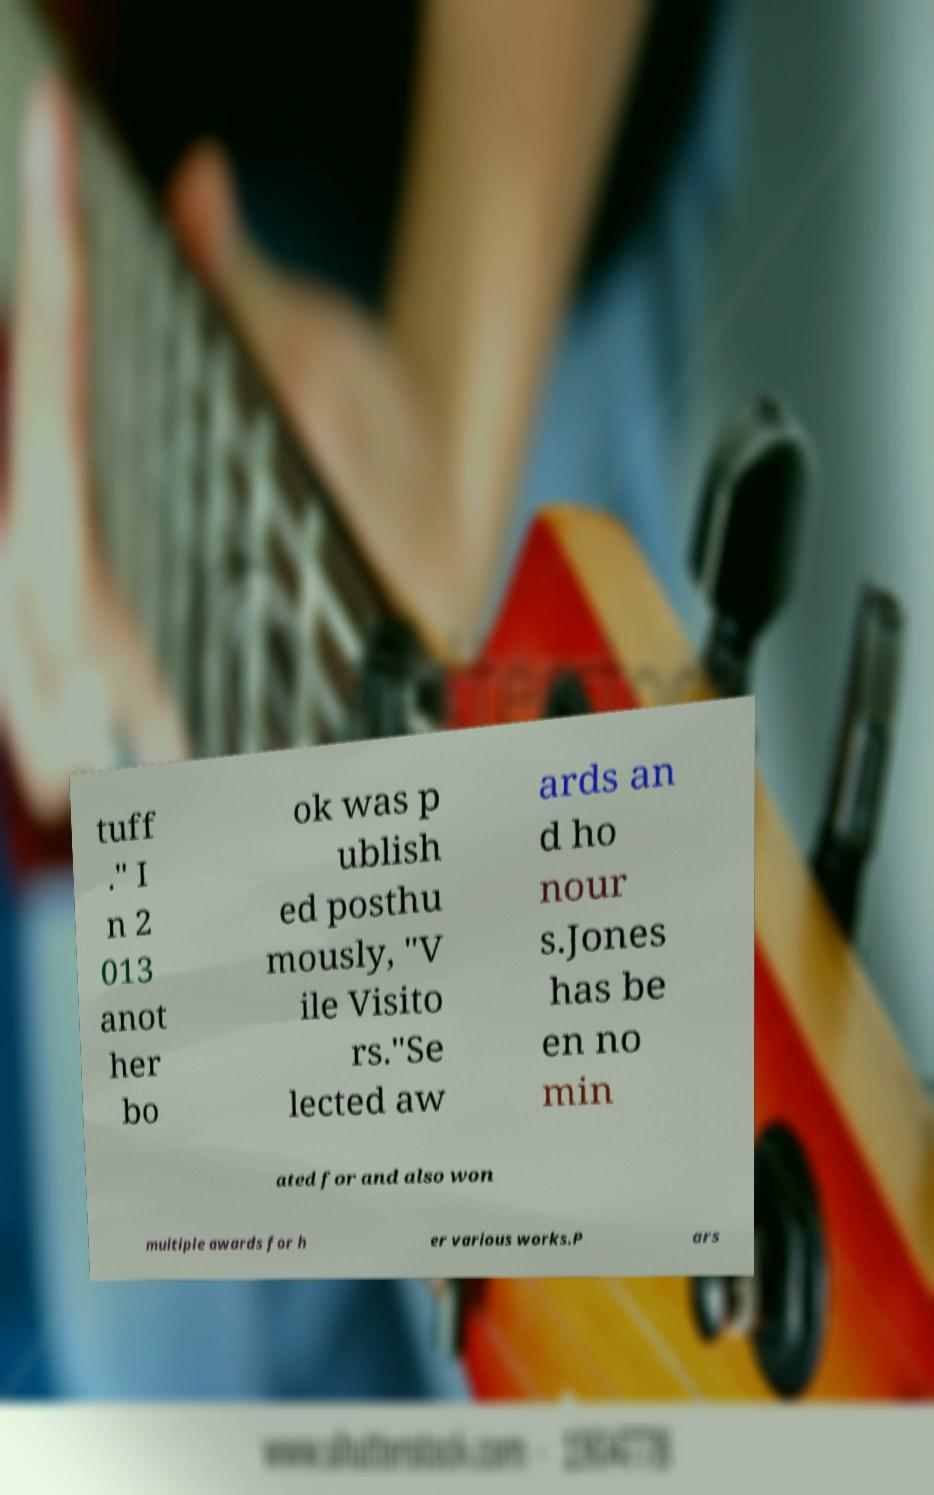Please read and relay the text visible in this image. What does it say? tuff ." I n 2 013 anot her bo ok was p ublish ed posthu mously, "V ile Visito rs."Se lected aw ards an d ho nour s.Jones has be en no min ated for and also won multiple awards for h er various works.P ars 